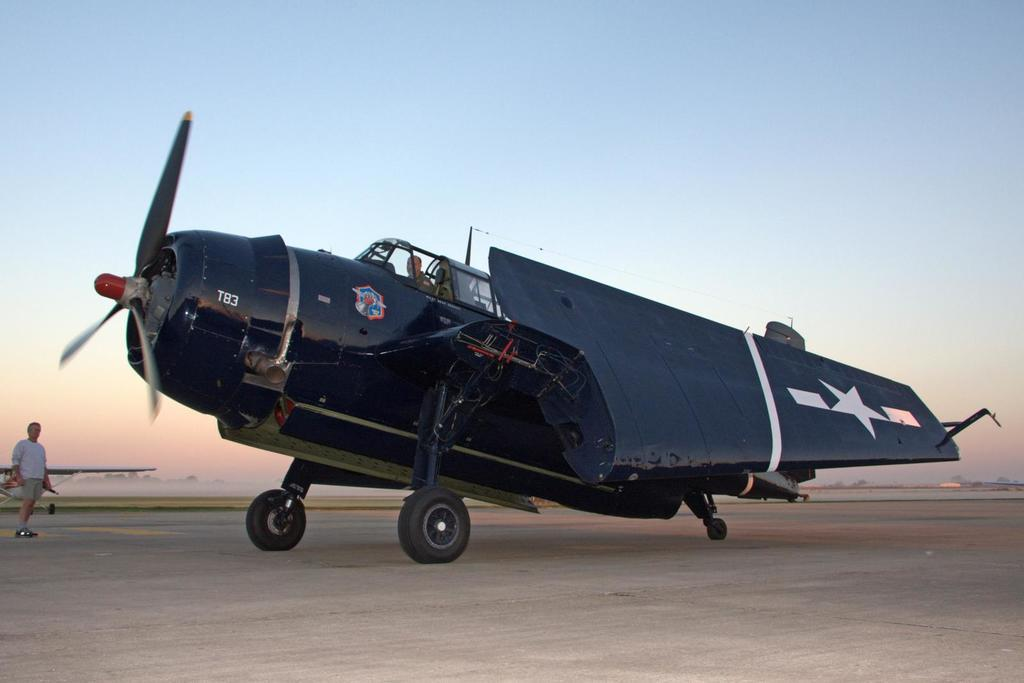Provide a one-sentence caption for the provided image. An aircraft numbered T83 sitting on the runway. 